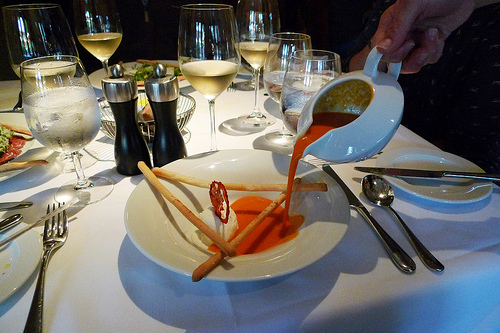<image>
Can you confirm if the spoon is to the left of the plate? No. The spoon is not to the left of the plate. From this viewpoint, they have a different horizontal relationship. 